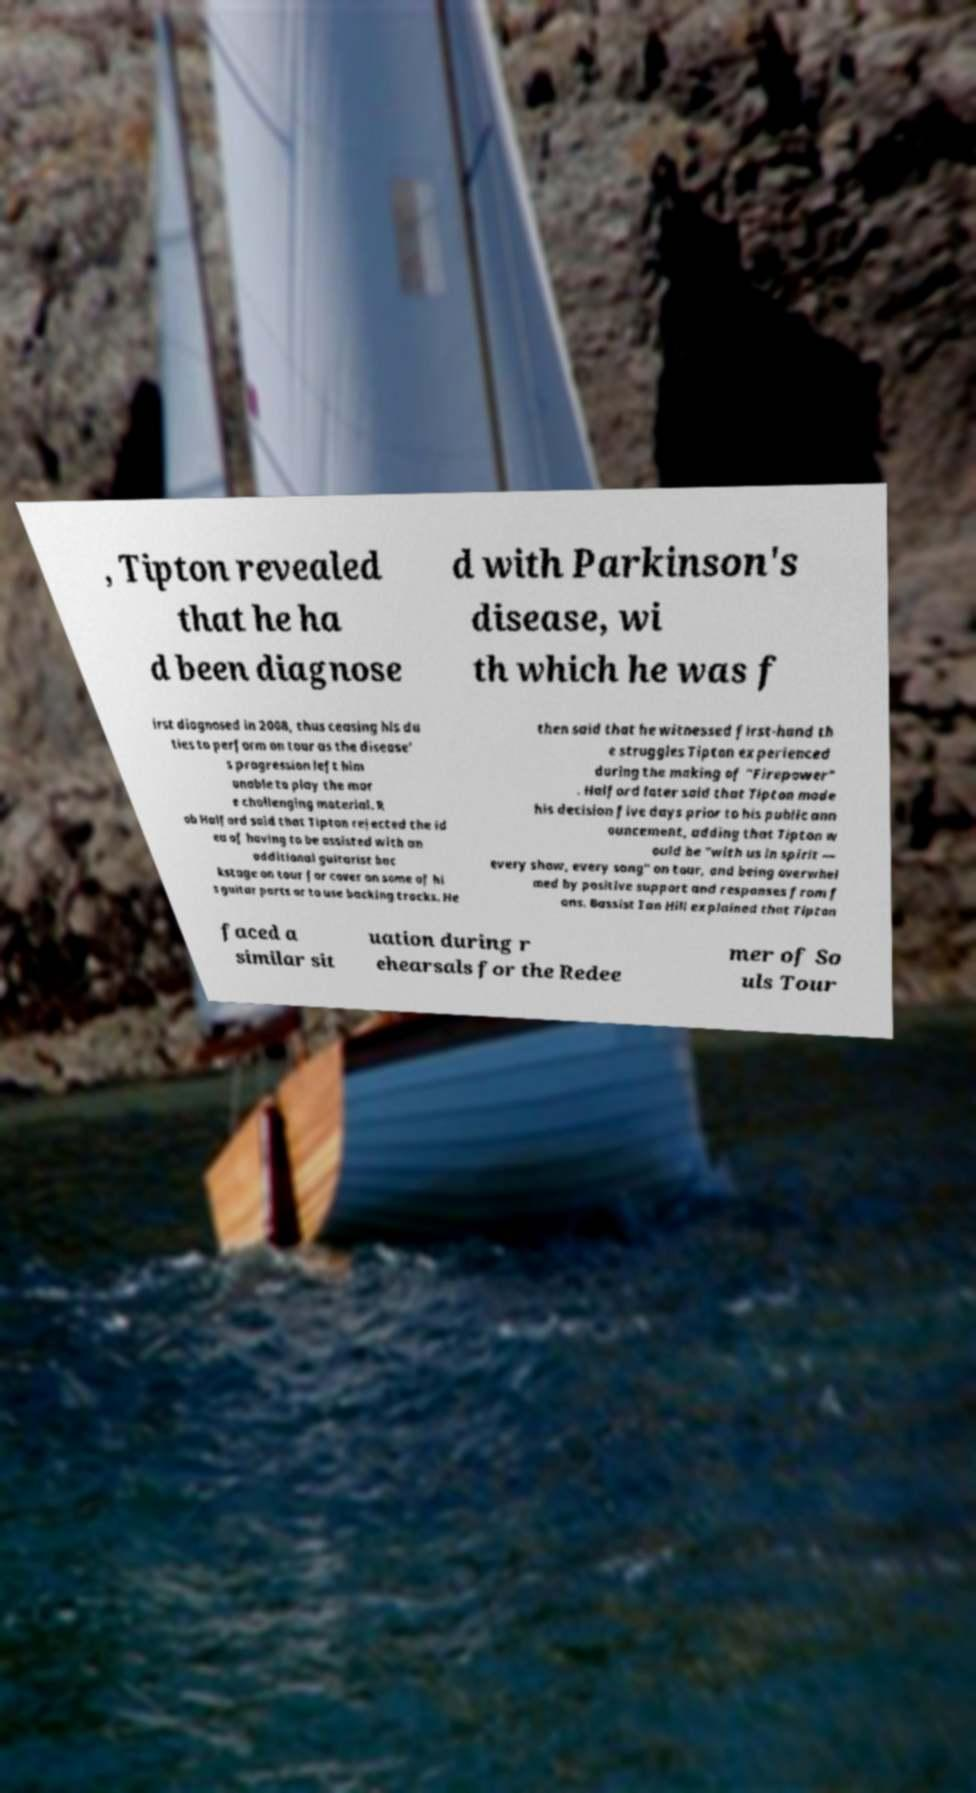I need the written content from this picture converted into text. Can you do that? , Tipton revealed that he ha d been diagnose d with Parkinson's disease, wi th which he was f irst diagnosed in 2008, thus ceasing his du ties to perform on tour as the disease' s progression left him unable to play the mor e challenging material. R ob Halford said that Tipton rejected the id ea of having to be assisted with an additional guitarist bac kstage on tour for cover on some of hi s guitar parts or to use backing tracks. He then said that he witnessed first-hand th e struggles Tipton experienced during the making of "Firepower" . Halford later said that Tipton made his decision five days prior to his public ann ouncement, adding that Tipton w ould be "with us in spirit — every show, every song" on tour, and being overwhel med by positive support and responses from f ans. Bassist Ian Hill explained that Tipton faced a similar sit uation during r ehearsals for the Redee mer of So uls Tour 